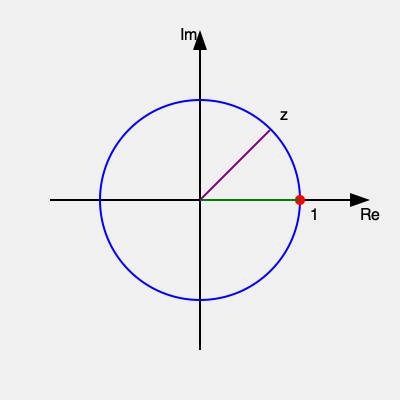Consider the complex function $f(z) = \frac{1}{z-1}$ illustrated on the Argand diagram above. What is the nature of the singularity at $z = 1$, and what is the residue of $f(z)$ at this point? To determine the nature of the singularity and calculate the residue, we'll follow these steps:

1) First, let's examine the function $f(z) = \frac{1}{z-1}$. The point $z = 1$ is clearly a singularity, as the denominator becomes zero at this point.

2) To classify the singularity, we need to look at the behavior of the function near $z = 1$. We can do this by considering the Laurent series expansion of $f(z)$ about $z = 1$:

   $f(z) = \frac{1}{z-1} = -\frac{1}{1-(z-1)} = -[1 + (z-1) + (z-1)^2 + ...]$

3) This expansion has only one term with a negative power of $(z-1)$, namely $\frac{1}{z-1}$. This indicates that $z = 1$ is a simple pole (or first-order pole) of $f(z)$.

4) For a simple pole, the residue is equal to the coefficient of the $\frac{1}{z-1}$ term in the Laurent series expansion. In this case, that coefficient is 1.

5) We can also calculate the residue using the limit formula for simple poles:

   $\text{Res}(f, 1) = \lim_{z \to 1} (z-1)f(z) = \lim_{z \to 1} (z-1)\frac{1}{z-1} = \lim_{z \to 1} 1 = 1$

6) Both methods confirm that the residue is 1.
Answer: Simple pole with residue 1 